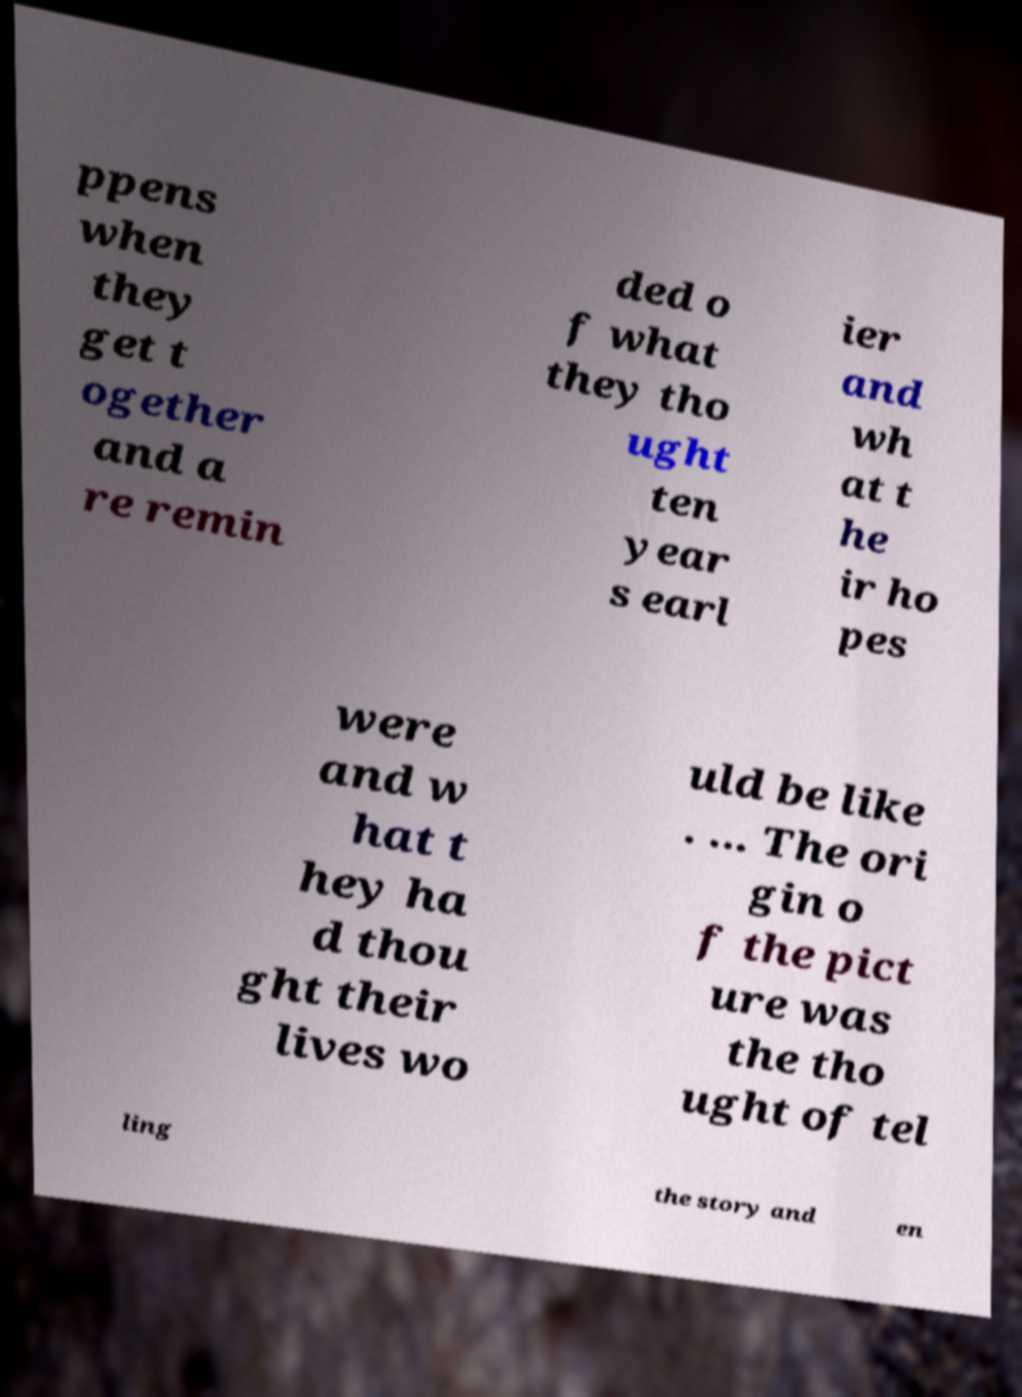I need the written content from this picture converted into text. Can you do that? ppens when they get t ogether and a re remin ded o f what they tho ught ten year s earl ier and wh at t he ir ho pes were and w hat t hey ha d thou ght their lives wo uld be like . ... The ori gin o f the pict ure was the tho ught of tel ling the story and en 